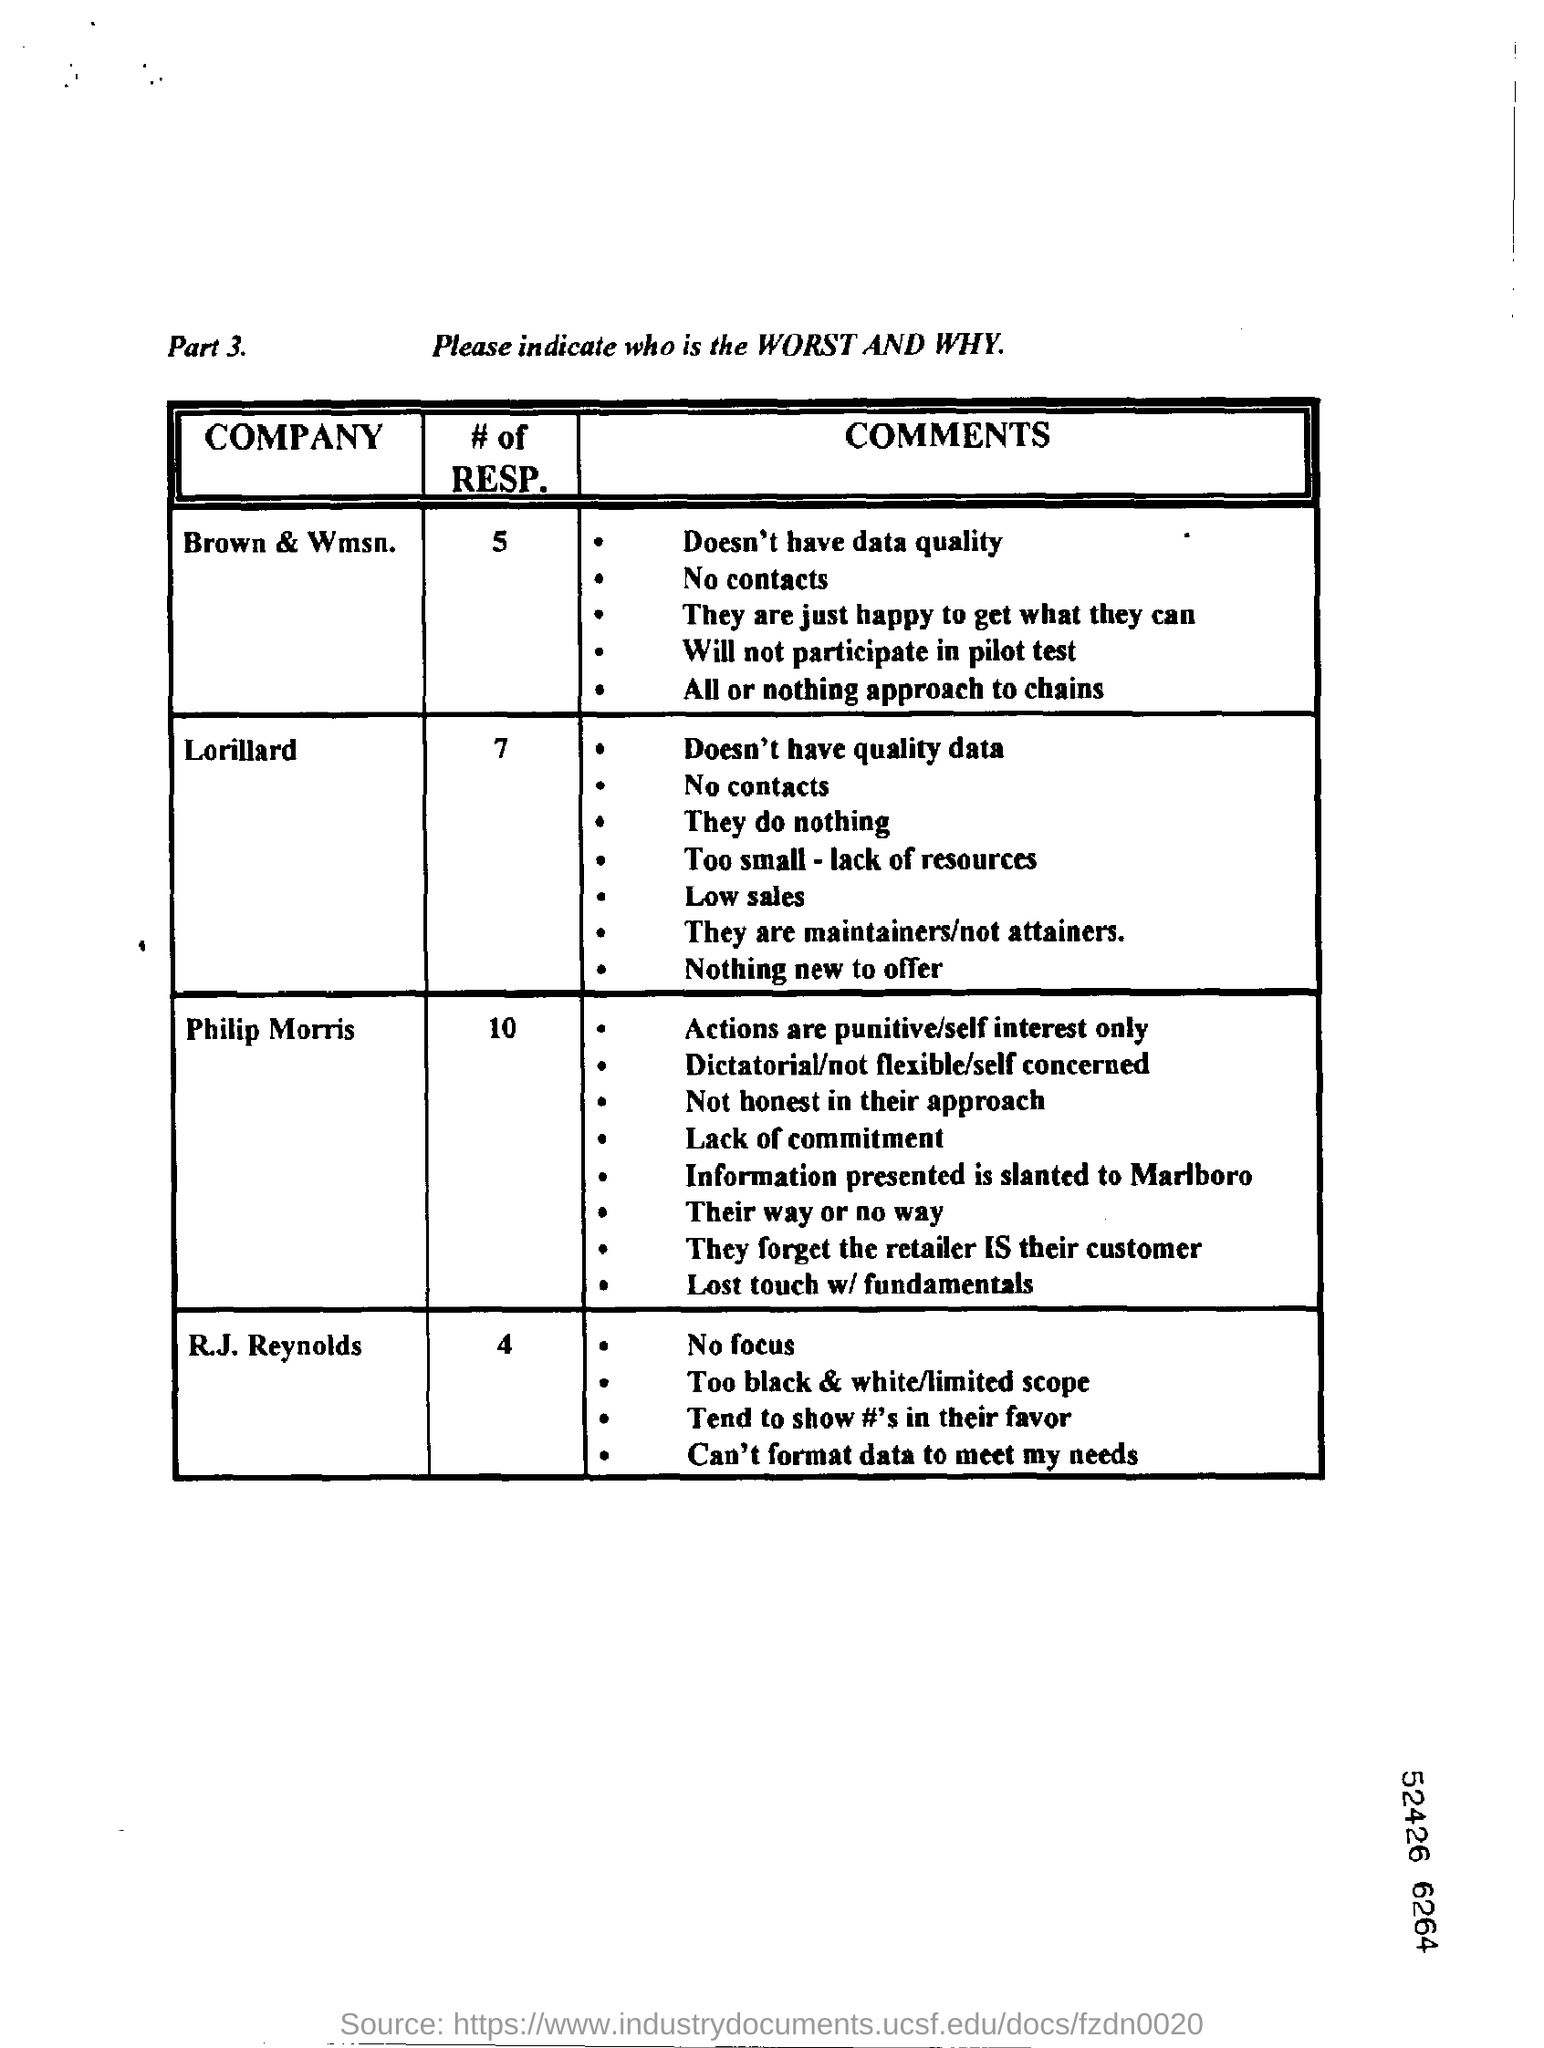Which company will not participate in pilot test?
Offer a terse response. Brown  & wmsn. Whose actions are punitive/self interest only?
Your answer should be compact. Philip morris. 